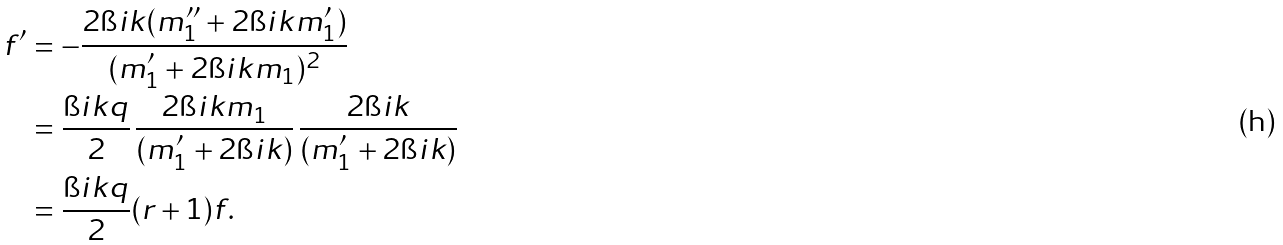Convert formula to latex. <formula><loc_0><loc_0><loc_500><loc_500>f ^ { \prime } & = - \frac { 2 \i i k ( m _ { 1 } ^ { \prime \prime } + 2 \i i k m _ { 1 } ^ { \prime } ) } { ( m _ { 1 } ^ { \prime } + 2 \i i k m _ { 1 } ) ^ { 2 } } \\ & = \frac { \i i k q } { 2 } \, \frac { 2 \i i k m _ { 1 } } { ( m _ { 1 } ^ { \prime } + 2 \i i k ) } \, \frac { 2 \i i k } { ( m _ { 1 } ^ { \prime } + 2 \i i k ) } \\ & = \frac { \i i k q } { 2 } ( r + 1 ) f .</formula> 